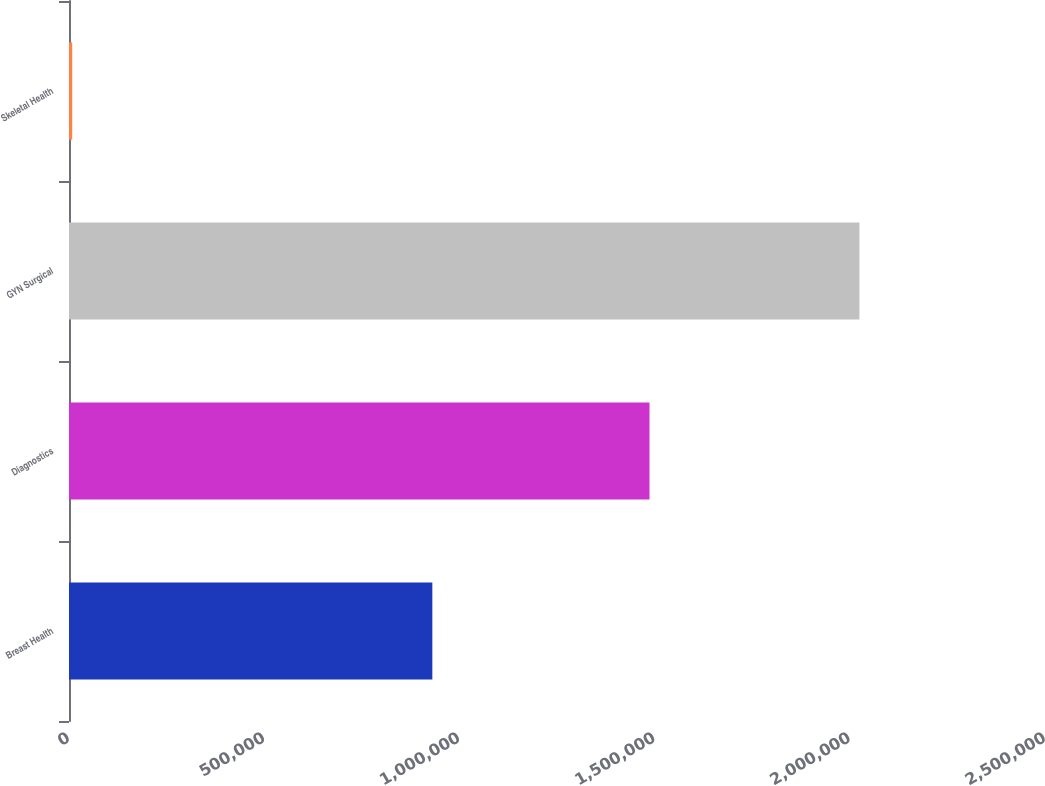<chart> <loc_0><loc_0><loc_500><loc_500><bar_chart><fcel>Breast Health<fcel>Diagnostics<fcel>GYN Surgical<fcel>Skeletal Health<nl><fcel>930672<fcel>1.48699e+06<fcel>2.02464e+06<fcel>8197<nl></chart> 